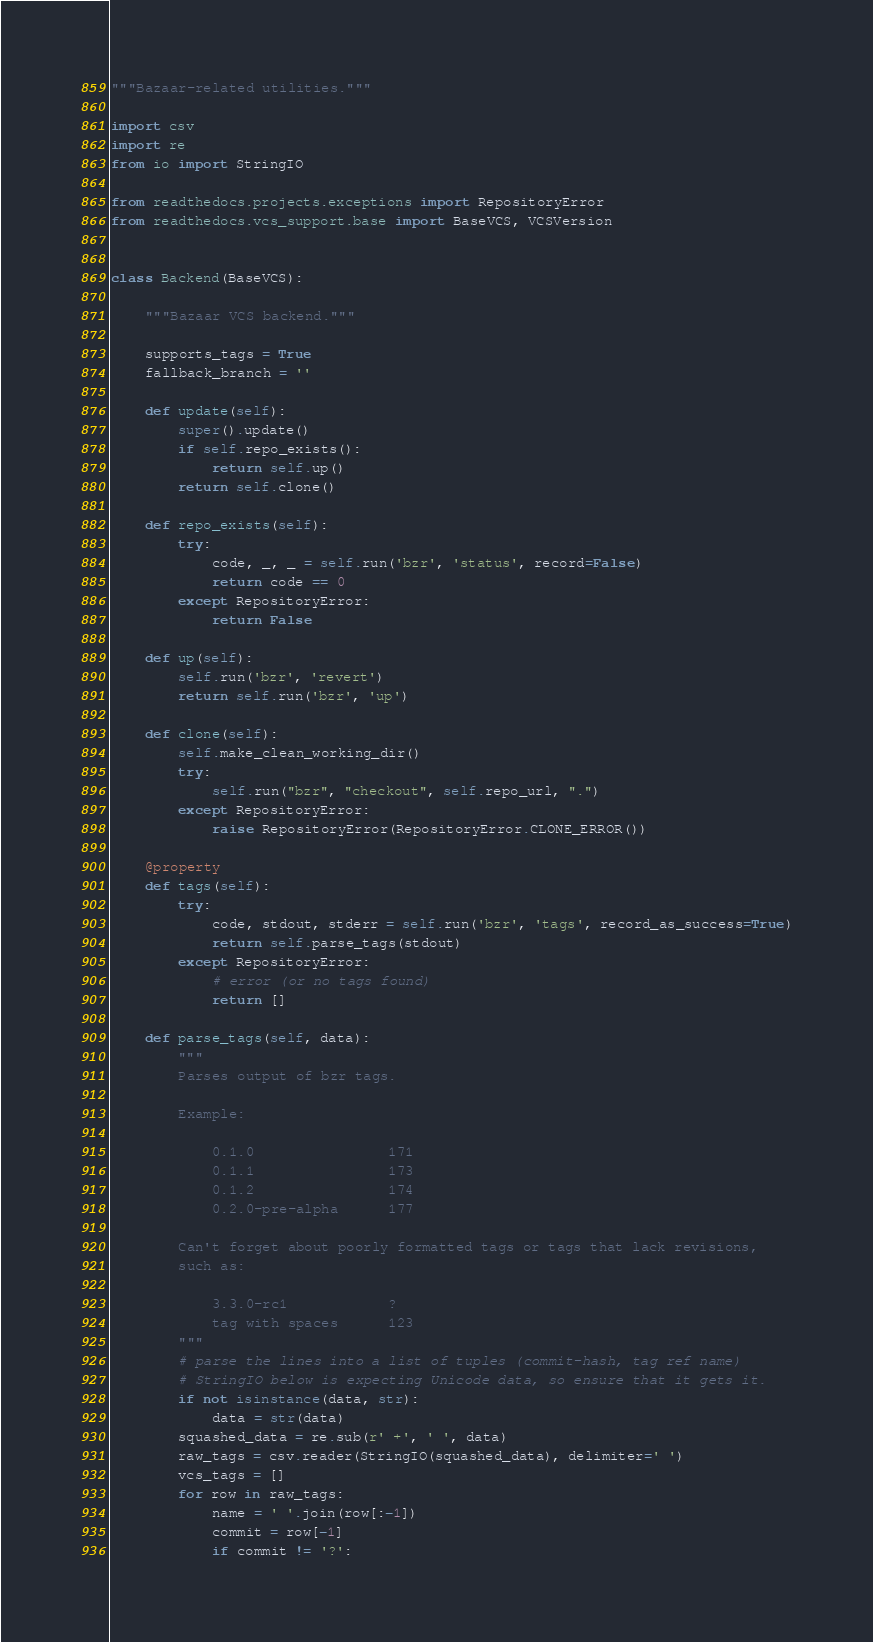Convert code to text. <code><loc_0><loc_0><loc_500><loc_500><_Python_>
"""Bazaar-related utilities."""

import csv
import re
from io import StringIO

from readthedocs.projects.exceptions import RepositoryError
from readthedocs.vcs_support.base import BaseVCS, VCSVersion


class Backend(BaseVCS):

    """Bazaar VCS backend."""

    supports_tags = True
    fallback_branch = ''

    def update(self):
        super().update()
        if self.repo_exists():
            return self.up()
        return self.clone()

    def repo_exists(self):
        try:
            code, _, _ = self.run('bzr', 'status', record=False)
            return code == 0
        except RepositoryError:
            return False

    def up(self):
        self.run('bzr', 'revert')
        return self.run('bzr', 'up')

    def clone(self):
        self.make_clean_working_dir()
        try:
            self.run("bzr", "checkout", self.repo_url, ".")
        except RepositoryError:
            raise RepositoryError(RepositoryError.CLONE_ERROR())

    @property
    def tags(self):
        try:
            code, stdout, stderr = self.run('bzr', 'tags', record_as_success=True)
            return self.parse_tags(stdout)
        except RepositoryError:
            # error (or no tags found)
            return []

    def parse_tags(self, data):
        """
        Parses output of bzr tags.

        Example:

            0.1.0                171
            0.1.1                173
            0.1.2                174
            0.2.0-pre-alpha      177

        Can't forget about poorly formatted tags or tags that lack revisions,
        such as:

            3.3.0-rc1            ?
            tag with spaces      123
        """
        # parse the lines into a list of tuples (commit-hash, tag ref name)
        # StringIO below is expecting Unicode data, so ensure that it gets it.
        if not isinstance(data, str):
            data = str(data)
        squashed_data = re.sub(r' +', ' ', data)
        raw_tags = csv.reader(StringIO(squashed_data), delimiter=' ')
        vcs_tags = []
        for row in raw_tags:
            name = ' '.join(row[:-1])
            commit = row[-1]
            if commit != '?':</code> 